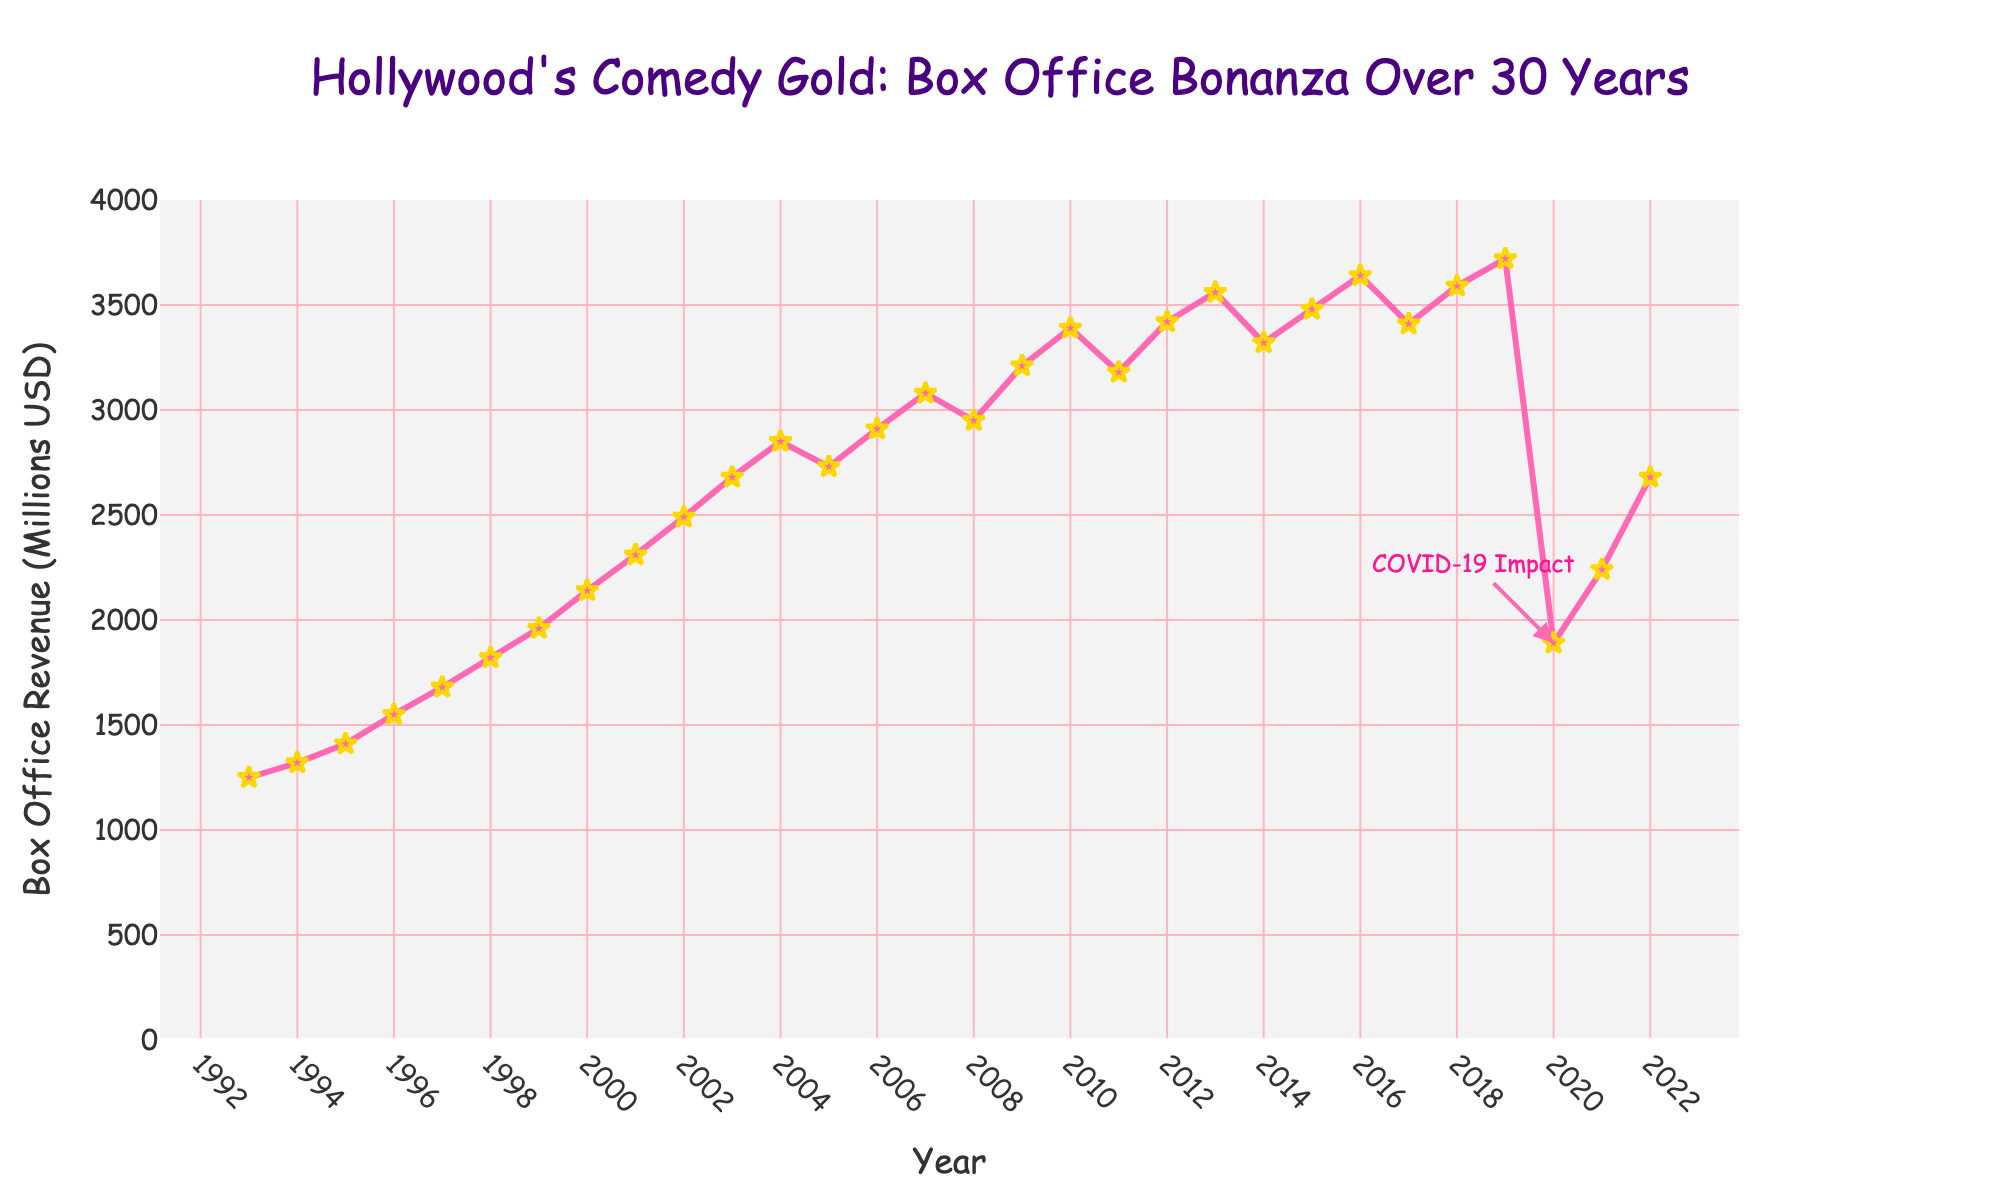What's the highest revenue year for comedy films? The plot shows the trend of box office revenue for comedy films, and the highest peak can be seen in 2019 just before the sharp decline due to COVID-19 impact in 2020.
Answer: 2019 How did the box office revenue change from 2008 to 2009? To determine the change, subtract the 2008 revenue (2950 million USD) from the 2009 revenue (3210 million USD). The result is a positive difference indicating an increase.
Answer: 260 million USD increase Why is there a sharp decline in box office revenue in 2020? The plot includes an annotation near the year 2020 that indicates the COVID-19 impact, which caused the sharp decline.
Answer: COVID-19 impact What is the average box office revenue from 2010 to 2020? First, sum the revenues from 2010 to 2020, then divide by the number of years (11). (3390 + 3180 + 3420 + 3560 + 3320 + 3480 + 3640 + 3410 + 3590 + 3720 + 1890) / 11.
Answer: Approximately 3365.45 million USD Which year had a lower box office revenue: 2005 or 2006? Compare the revenues for the years 2005 (2730 million USD) and 2006 (2910 million USD). The revenue in 2005 is lower than in 2006.
Answer: 2005 Is there a clear trend in box office revenue from 1993 to 2003? Observing the line chart, the trend from 1993 to 2003 shows a consistent increase in box office revenue for comedy films every year.
Answer: Yes What is the overall trend of box office revenue from 1993 to 2022? The trend starts with a steady increase from 1993, peaking in 2019, followed by a sharp decline in 2020, partially recovering in 2021 and 2022.
Answer: Increase, peak at 2019, then decline in 2020, partial recovery How much did the box office revenue drop from 2019 to 2020? Subtract the 2020 revenue (1890 million USD) from the 2019 revenue (3720 million USD) to find the drop amount.
Answer: 1830 million USD drop In which time period did the box office revenue see a consistent year-to-year increase without any decline? From observing the plot, the period from 1993 to 2004 had a year-to-year increase in revenue without any decline.
Answer: 1993 to 2004 How does the box office revenue in 2022 compare to the revenue in 2018? Compare the revenues for the years 2022 (2680 million USD) and 2018 (3590 million USD). The revenue in 2022 is lower than in 2018.
Answer: 2018 had higher revenue 